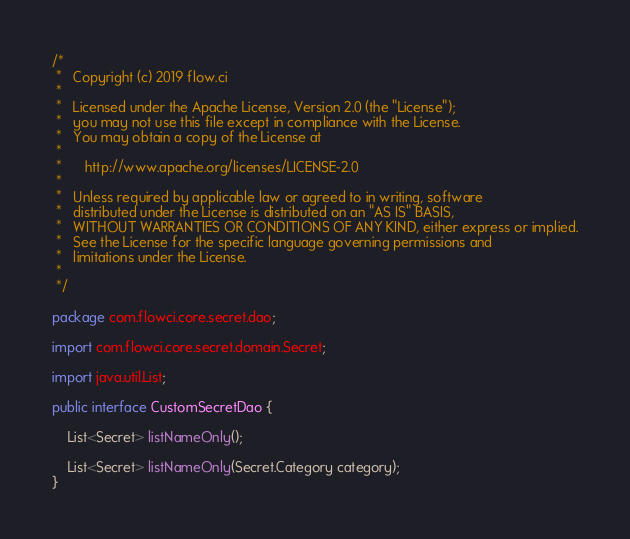Convert code to text. <code><loc_0><loc_0><loc_500><loc_500><_Java_>/*
 *   Copyright (c) 2019 flow.ci
 *
 *   Licensed under the Apache License, Version 2.0 (the "License");
 *   you may not use this file except in compliance with the License.
 *   You may obtain a copy of the License at
 *
 *      http://www.apache.org/licenses/LICENSE-2.0
 *
 *   Unless required by applicable law or agreed to in writing, software
 *   distributed under the License is distributed on an "AS IS" BASIS,
 *   WITHOUT WARRANTIES OR CONDITIONS OF ANY KIND, either express or implied.
 *   See the License for the specific language governing permissions and
 *   limitations under the License.
 *
 */

package com.flowci.core.secret.dao;

import com.flowci.core.secret.domain.Secret;

import java.util.List;

public interface CustomSecretDao {

    List<Secret> listNameOnly();

    List<Secret> listNameOnly(Secret.Category category);
}
</code> 